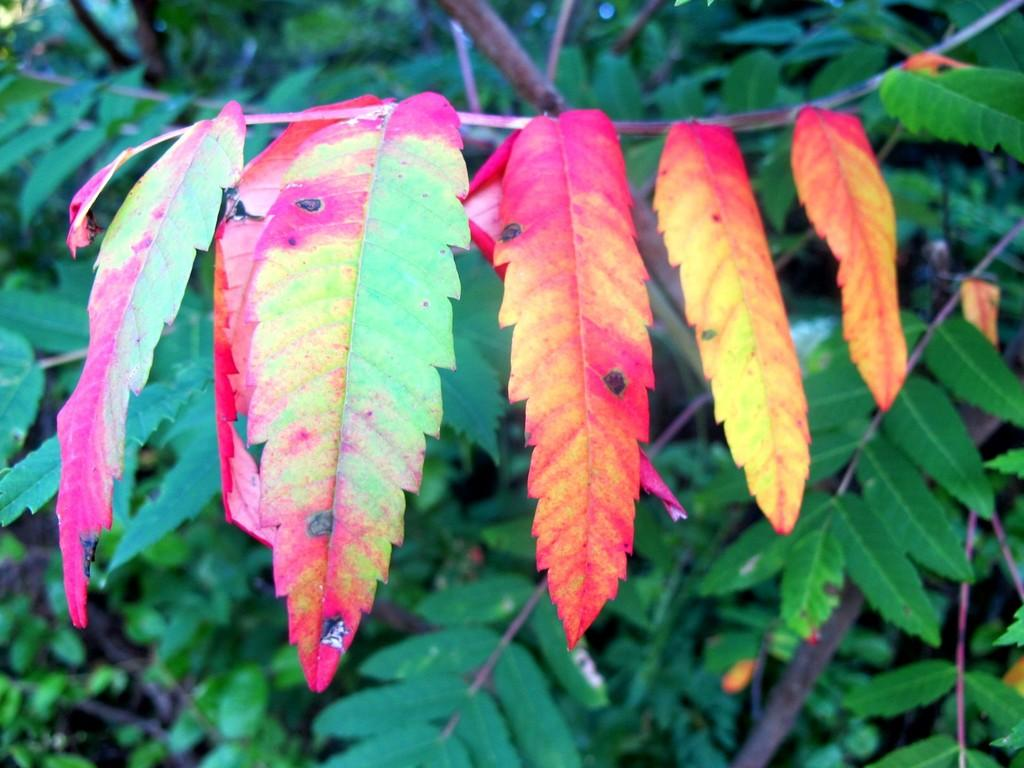What type of vegetation can be seen in the image? There are leaves and tree branches in the image. Can you describe the specific parts of the trees that are visible? Yes, tree branches are visible in the image. What type of noise can be heard coming from the harbor in the image? There is no harbor present in the image, so it's not possible to determine what, if any, noise might be heard. 